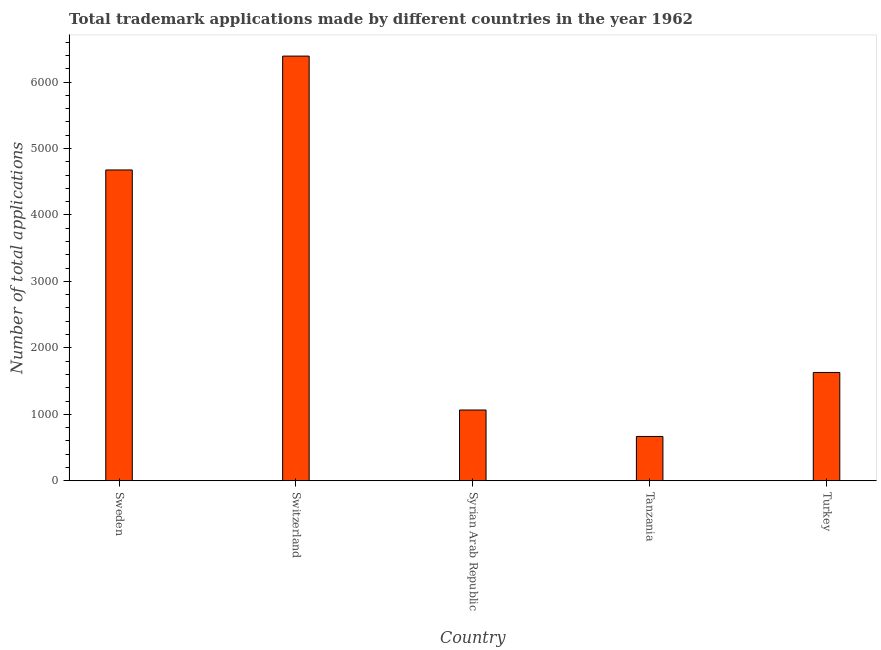Does the graph contain any zero values?
Give a very brief answer. No. Does the graph contain grids?
Provide a succinct answer. No. What is the title of the graph?
Provide a succinct answer. Total trademark applications made by different countries in the year 1962. What is the label or title of the X-axis?
Your response must be concise. Country. What is the label or title of the Y-axis?
Your response must be concise. Number of total applications. What is the number of trademark applications in Sweden?
Offer a terse response. 4677. Across all countries, what is the maximum number of trademark applications?
Provide a succinct answer. 6390. Across all countries, what is the minimum number of trademark applications?
Offer a terse response. 667. In which country was the number of trademark applications maximum?
Provide a short and direct response. Switzerland. In which country was the number of trademark applications minimum?
Provide a short and direct response. Tanzania. What is the sum of the number of trademark applications?
Keep it short and to the point. 1.44e+04. What is the difference between the number of trademark applications in Sweden and Turkey?
Provide a short and direct response. 3047. What is the average number of trademark applications per country?
Your answer should be very brief. 2885. What is the median number of trademark applications?
Offer a terse response. 1630. What is the ratio of the number of trademark applications in Switzerland to that in Turkey?
Your response must be concise. 3.92. What is the difference between the highest and the second highest number of trademark applications?
Offer a terse response. 1713. Is the sum of the number of trademark applications in Syrian Arab Republic and Tanzania greater than the maximum number of trademark applications across all countries?
Give a very brief answer. No. What is the difference between the highest and the lowest number of trademark applications?
Offer a terse response. 5723. In how many countries, is the number of trademark applications greater than the average number of trademark applications taken over all countries?
Provide a short and direct response. 2. Are all the bars in the graph horizontal?
Make the answer very short. No. How many countries are there in the graph?
Provide a succinct answer. 5. What is the Number of total applications of Sweden?
Your response must be concise. 4677. What is the Number of total applications of Switzerland?
Offer a very short reply. 6390. What is the Number of total applications of Syrian Arab Republic?
Your answer should be very brief. 1065. What is the Number of total applications in Tanzania?
Your response must be concise. 667. What is the Number of total applications of Turkey?
Keep it short and to the point. 1630. What is the difference between the Number of total applications in Sweden and Switzerland?
Offer a terse response. -1713. What is the difference between the Number of total applications in Sweden and Syrian Arab Republic?
Offer a very short reply. 3612. What is the difference between the Number of total applications in Sweden and Tanzania?
Give a very brief answer. 4010. What is the difference between the Number of total applications in Sweden and Turkey?
Offer a very short reply. 3047. What is the difference between the Number of total applications in Switzerland and Syrian Arab Republic?
Give a very brief answer. 5325. What is the difference between the Number of total applications in Switzerland and Tanzania?
Make the answer very short. 5723. What is the difference between the Number of total applications in Switzerland and Turkey?
Give a very brief answer. 4760. What is the difference between the Number of total applications in Syrian Arab Republic and Tanzania?
Ensure brevity in your answer.  398. What is the difference between the Number of total applications in Syrian Arab Republic and Turkey?
Ensure brevity in your answer.  -565. What is the difference between the Number of total applications in Tanzania and Turkey?
Ensure brevity in your answer.  -963. What is the ratio of the Number of total applications in Sweden to that in Switzerland?
Provide a succinct answer. 0.73. What is the ratio of the Number of total applications in Sweden to that in Syrian Arab Republic?
Your response must be concise. 4.39. What is the ratio of the Number of total applications in Sweden to that in Tanzania?
Keep it short and to the point. 7.01. What is the ratio of the Number of total applications in Sweden to that in Turkey?
Offer a terse response. 2.87. What is the ratio of the Number of total applications in Switzerland to that in Tanzania?
Your answer should be very brief. 9.58. What is the ratio of the Number of total applications in Switzerland to that in Turkey?
Your answer should be very brief. 3.92. What is the ratio of the Number of total applications in Syrian Arab Republic to that in Tanzania?
Provide a short and direct response. 1.6. What is the ratio of the Number of total applications in Syrian Arab Republic to that in Turkey?
Keep it short and to the point. 0.65. What is the ratio of the Number of total applications in Tanzania to that in Turkey?
Provide a short and direct response. 0.41. 